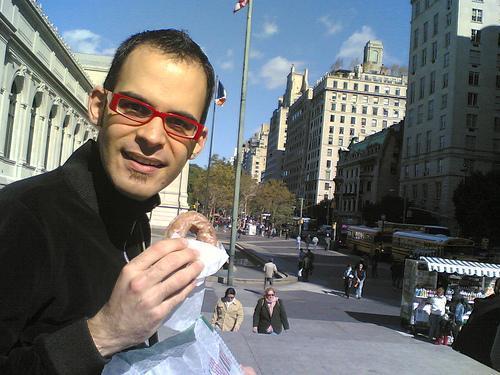How many flags are visible?
Give a very brief answer. 2. How many giraffes are there?
Give a very brief answer. 0. 